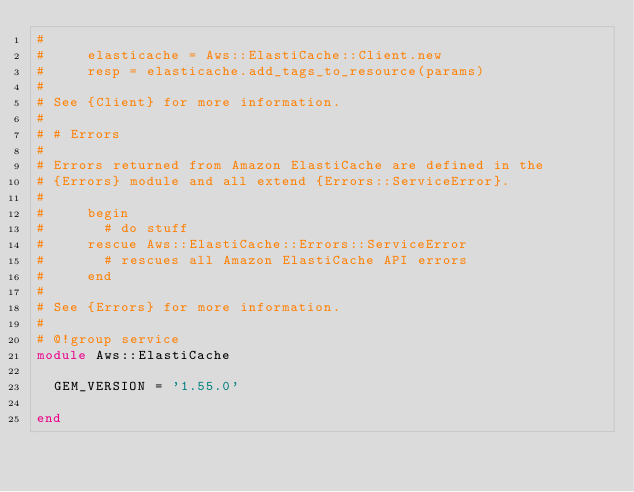Convert code to text. <code><loc_0><loc_0><loc_500><loc_500><_Ruby_>#
#     elasticache = Aws::ElastiCache::Client.new
#     resp = elasticache.add_tags_to_resource(params)
#
# See {Client} for more information.
#
# # Errors
#
# Errors returned from Amazon ElastiCache are defined in the
# {Errors} module and all extend {Errors::ServiceError}.
#
#     begin
#       # do stuff
#     rescue Aws::ElastiCache::Errors::ServiceError
#       # rescues all Amazon ElastiCache API errors
#     end
#
# See {Errors} for more information.
#
# @!group service
module Aws::ElastiCache

  GEM_VERSION = '1.55.0'

end
</code> 